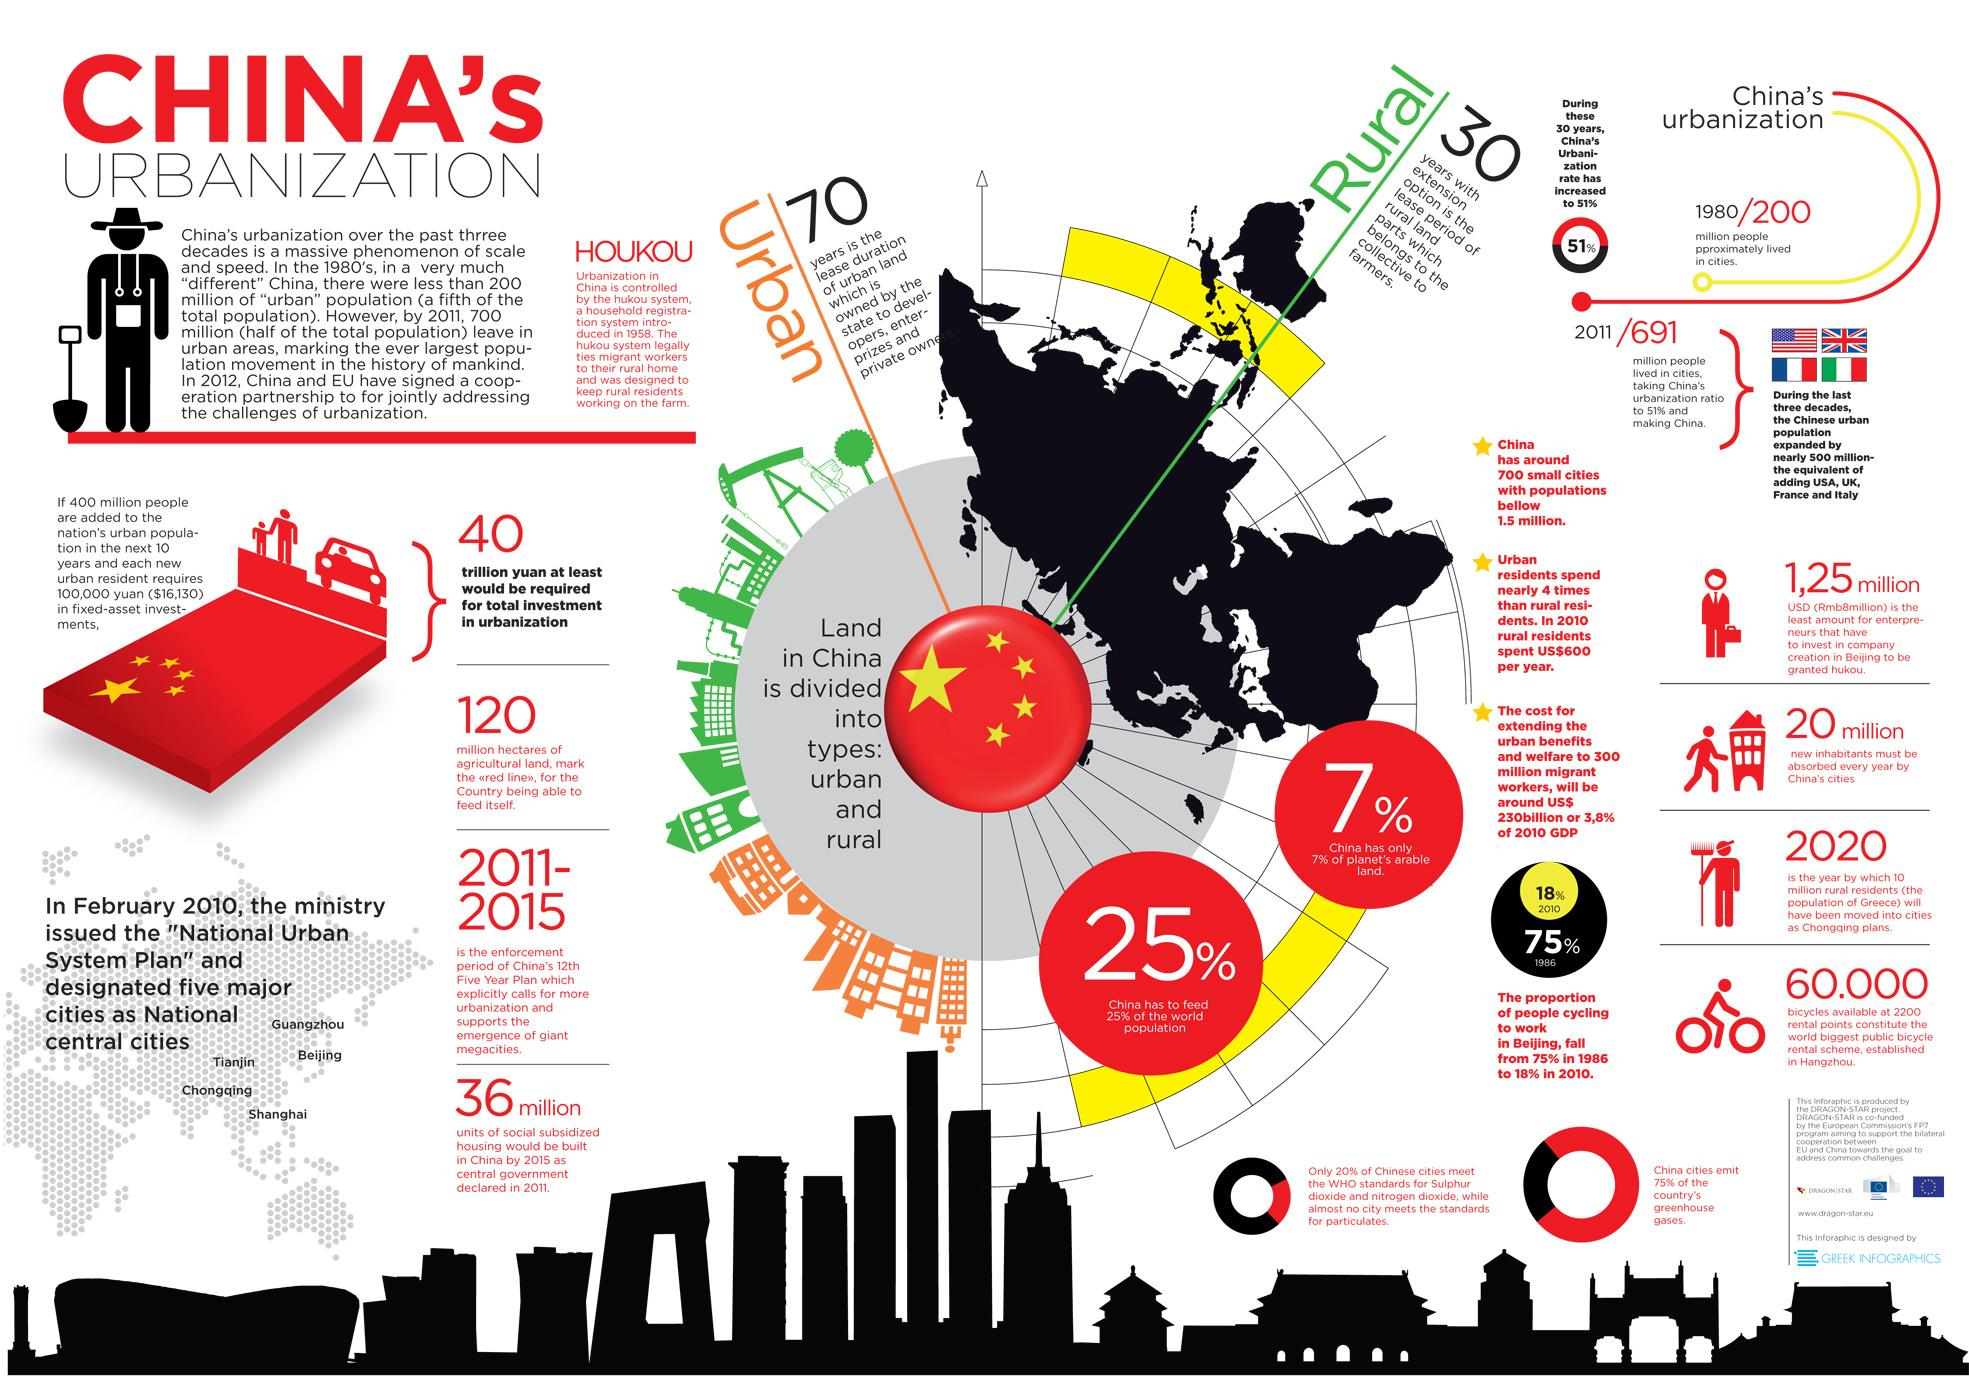Highlight a few significant elements in this photo. It is estimated that approximately 75% of the world's population is not fed by China. Ninety-three percent of the planet's arable land is not located in China. 